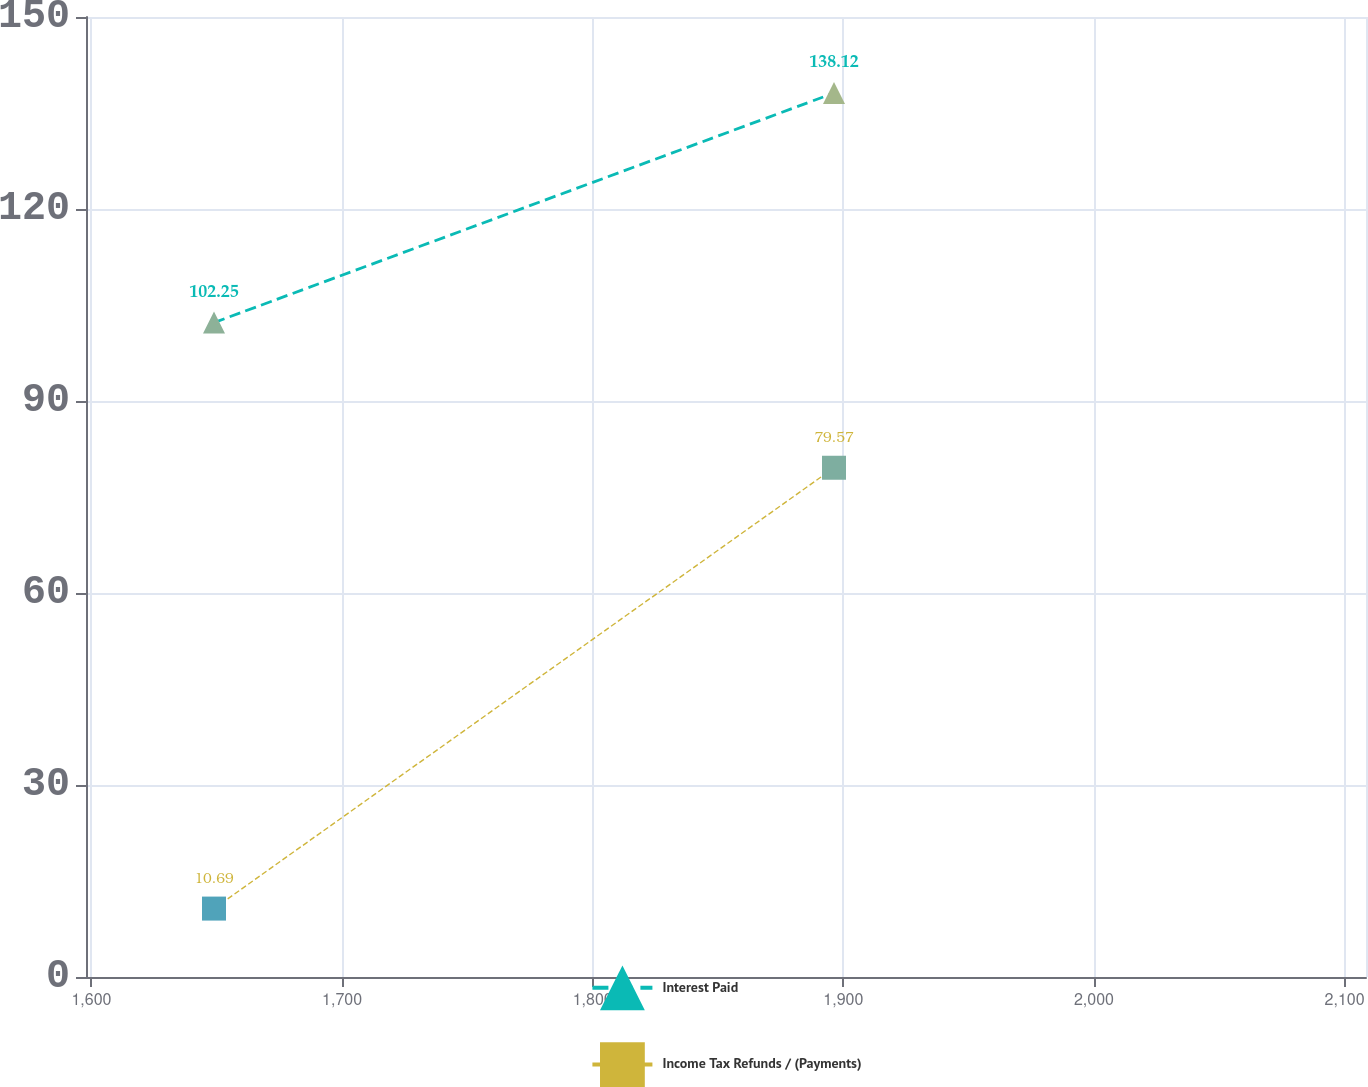<chart> <loc_0><loc_0><loc_500><loc_500><line_chart><ecel><fcel>Interest Paid<fcel>Income Tax Refunds / (Payments)<nl><fcel>1648.9<fcel>102.25<fcel>10.69<nl><fcel>1896.29<fcel>138.12<fcel>79.57<nl><fcel>2159.63<fcel>240.84<fcel>476.48<nl></chart> 